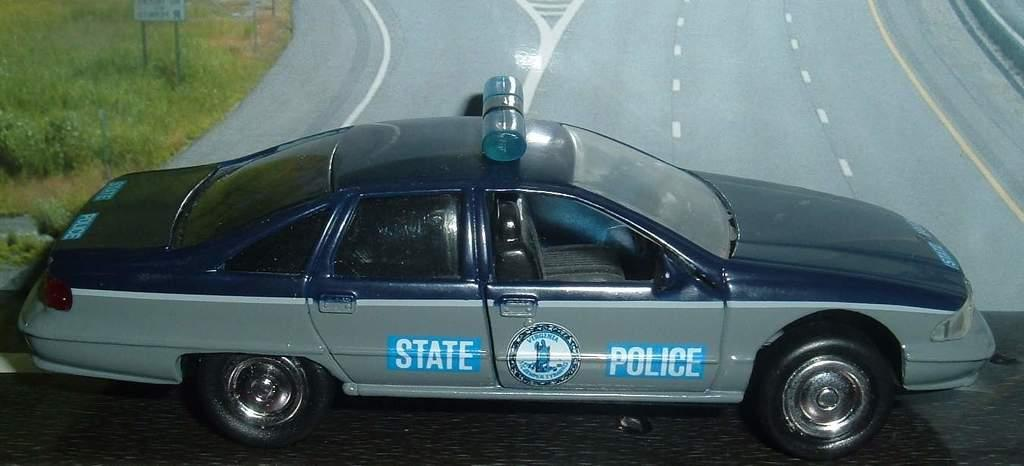What is the main subject of the image? The main subject of the image is a car. Can you describe the color of the car? The car is black and gray in color. Where is the car located in the image? The car is on the road. What type of vegetation can be seen in the background of the image? The background of the image includes grass. What is the color of the grass? The grass is green in color. What type of brass instrument is being played by the son in the image? There is no brass instrument or son present in the image; it features a black and gray car on the road with a green grass background. 